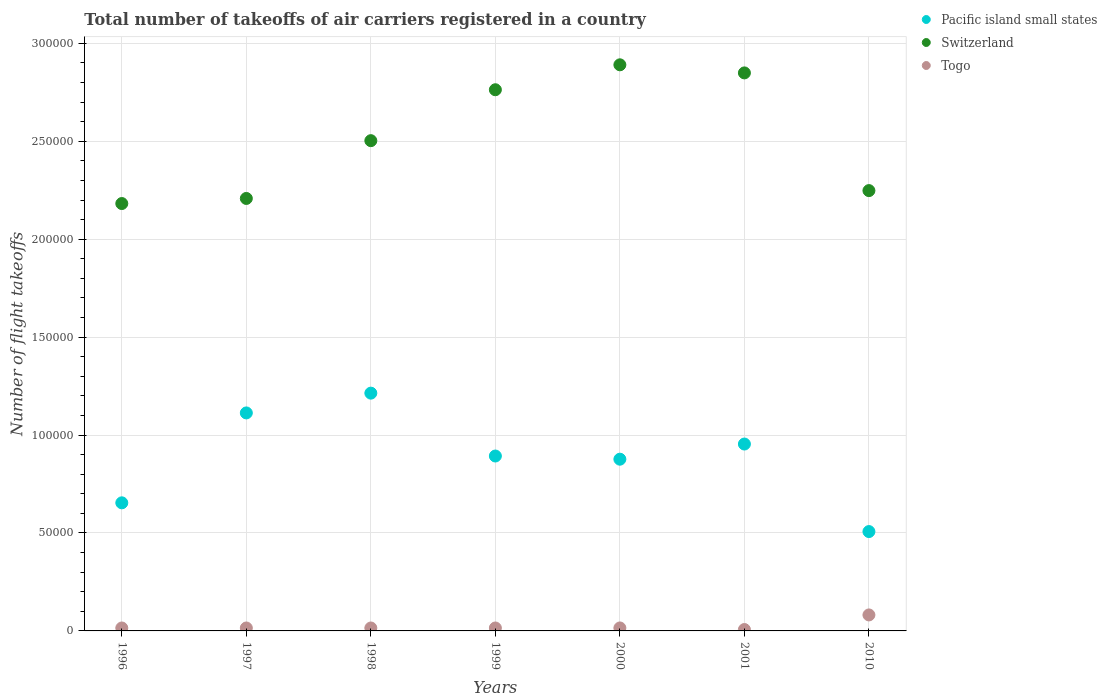How many different coloured dotlines are there?
Your response must be concise. 3. What is the total number of flight takeoffs in Togo in 2001?
Your response must be concise. 716. Across all years, what is the maximum total number of flight takeoffs in Pacific island small states?
Keep it short and to the point. 1.21e+05. Across all years, what is the minimum total number of flight takeoffs in Pacific island small states?
Provide a short and direct response. 5.07e+04. What is the total total number of flight takeoffs in Switzerland in the graph?
Keep it short and to the point. 1.76e+06. What is the difference between the total number of flight takeoffs in Togo in 2000 and that in 2001?
Your answer should be very brief. 802. What is the difference between the total number of flight takeoffs in Switzerland in 1999 and the total number of flight takeoffs in Togo in 2001?
Your answer should be compact. 2.76e+05. What is the average total number of flight takeoffs in Switzerland per year?
Your response must be concise. 2.52e+05. In the year 2001, what is the difference between the total number of flight takeoffs in Togo and total number of flight takeoffs in Switzerland?
Make the answer very short. -2.84e+05. What is the ratio of the total number of flight takeoffs in Togo in 1998 to that in 2000?
Your answer should be compact. 0.99. Is the total number of flight takeoffs in Switzerland in 2001 less than that in 2010?
Give a very brief answer. No. Is the difference between the total number of flight takeoffs in Togo in 1996 and 2010 greater than the difference between the total number of flight takeoffs in Switzerland in 1996 and 2010?
Ensure brevity in your answer.  No. What is the difference between the highest and the second highest total number of flight takeoffs in Switzerland?
Make the answer very short. 4132. What is the difference between the highest and the lowest total number of flight takeoffs in Pacific island small states?
Ensure brevity in your answer.  7.07e+04. In how many years, is the total number of flight takeoffs in Switzerland greater than the average total number of flight takeoffs in Switzerland taken over all years?
Your answer should be very brief. 3. Is the sum of the total number of flight takeoffs in Togo in 2000 and 2010 greater than the maximum total number of flight takeoffs in Switzerland across all years?
Your answer should be compact. No. Is it the case that in every year, the sum of the total number of flight takeoffs in Pacific island small states and total number of flight takeoffs in Togo  is greater than the total number of flight takeoffs in Switzerland?
Offer a very short reply. No. Is the total number of flight takeoffs in Pacific island small states strictly greater than the total number of flight takeoffs in Togo over the years?
Give a very brief answer. Yes. Is the total number of flight takeoffs in Togo strictly less than the total number of flight takeoffs in Switzerland over the years?
Provide a succinct answer. Yes. How many dotlines are there?
Give a very brief answer. 3. How many years are there in the graph?
Keep it short and to the point. 7. What is the difference between two consecutive major ticks on the Y-axis?
Offer a very short reply. 5.00e+04. Are the values on the major ticks of Y-axis written in scientific E-notation?
Your response must be concise. No. Does the graph contain grids?
Provide a short and direct response. Yes. What is the title of the graph?
Your answer should be compact. Total number of takeoffs of air carriers registered in a country. What is the label or title of the X-axis?
Provide a short and direct response. Years. What is the label or title of the Y-axis?
Provide a succinct answer. Number of flight takeoffs. What is the Number of flight takeoffs in Pacific island small states in 1996?
Offer a very short reply. 6.54e+04. What is the Number of flight takeoffs of Switzerland in 1996?
Your response must be concise. 2.18e+05. What is the Number of flight takeoffs in Togo in 1996?
Provide a short and direct response. 1500. What is the Number of flight takeoffs in Pacific island small states in 1997?
Ensure brevity in your answer.  1.11e+05. What is the Number of flight takeoffs of Switzerland in 1997?
Keep it short and to the point. 2.21e+05. What is the Number of flight takeoffs in Togo in 1997?
Ensure brevity in your answer.  1500. What is the Number of flight takeoffs of Pacific island small states in 1998?
Offer a terse response. 1.21e+05. What is the Number of flight takeoffs in Switzerland in 1998?
Ensure brevity in your answer.  2.50e+05. What is the Number of flight takeoffs of Togo in 1998?
Your answer should be compact. 1500. What is the Number of flight takeoffs of Pacific island small states in 1999?
Provide a succinct answer. 8.93e+04. What is the Number of flight takeoffs of Switzerland in 1999?
Provide a succinct answer. 2.76e+05. What is the Number of flight takeoffs of Togo in 1999?
Offer a very short reply. 1500. What is the Number of flight takeoffs in Pacific island small states in 2000?
Give a very brief answer. 8.77e+04. What is the Number of flight takeoffs of Switzerland in 2000?
Provide a succinct answer. 2.89e+05. What is the Number of flight takeoffs in Togo in 2000?
Offer a terse response. 1518. What is the Number of flight takeoffs of Pacific island small states in 2001?
Offer a terse response. 9.54e+04. What is the Number of flight takeoffs of Switzerland in 2001?
Provide a short and direct response. 2.85e+05. What is the Number of flight takeoffs in Togo in 2001?
Offer a very short reply. 716. What is the Number of flight takeoffs in Pacific island small states in 2010?
Ensure brevity in your answer.  5.07e+04. What is the Number of flight takeoffs in Switzerland in 2010?
Give a very brief answer. 2.25e+05. What is the Number of flight takeoffs in Togo in 2010?
Provide a short and direct response. 8164. Across all years, what is the maximum Number of flight takeoffs of Pacific island small states?
Provide a succinct answer. 1.21e+05. Across all years, what is the maximum Number of flight takeoffs in Switzerland?
Provide a succinct answer. 2.89e+05. Across all years, what is the maximum Number of flight takeoffs of Togo?
Provide a succinct answer. 8164. Across all years, what is the minimum Number of flight takeoffs of Pacific island small states?
Offer a terse response. 5.07e+04. Across all years, what is the minimum Number of flight takeoffs of Switzerland?
Provide a succinct answer. 2.18e+05. Across all years, what is the minimum Number of flight takeoffs of Togo?
Your response must be concise. 716. What is the total Number of flight takeoffs of Pacific island small states in the graph?
Keep it short and to the point. 6.21e+05. What is the total Number of flight takeoffs of Switzerland in the graph?
Your answer should be very brief. 1.76e+06. What is the total Number of flight takeoffs in Togo in the graph?
Offer a terse response. 1.64e+04. What is the difference between the Number of flight takeoffs of Pacific island small states in 1996 and that in 1997?
Provide a succinct answer. -4.59e+04. What is the difference between the Number of flight takeoffs of Switzerland in 1996 and that in 1997?
Keep it short and to the point. -2600. What is the difference between the Number of flight takeoffs in Pacific island small states in 1996 and that in 1998?
Your answer should be compact. -5.60e+04. What is the difference between the Number of flight takeoffs of Switzerland in 1996 and that in 1998?
Keep it short and to the point. -3.21e+04. What is the difference between the Number of flight takeoffs of Togo in 1996 and that in 1998?
Your answer should be very brief. 0. What is the difference between the Number of flight takeoffs in Pacific island small states in 1996 and that in 1999?
Offer a terse response. -2.39e+04. What is the difference between the Number of flight takeoffs in Switzerland in 1996 and that in 1999?
Provide a succinct answer. -5.81e+04. What is the difference between the Number of flight takeoffs of Pacific island small states in 1996 and that in 2000?
Offer a very short reply. -2.23e+04. What is the difference between the Number of flight takeoffs of Switzerland in 1996 and that in 2000?
Make the answer very short. -7.08e+04. What is the difference between the Number of flight takeoffs of Togo in 1996 and that in 2000?
Offer a very short reply. -18. What is the difference between the Number of flight takeoffs in Pacific island small states in 1996 and that in 2001?
Offer a terse response. -3.00e+04. What is the difference between the Number of flight takeoffs in Switzerland in 1996 and that in 2001?
Make the answer very short. -6.67e+04. What is the difference between the Number of flight takeoffs of Togo in 1996 and that in 2001?
Provide a succinct answer. 784. What is the difference between the Number of flight takeoffs in Pacific island small states in 1996 and that in 2010?
Offer a terse response. 1.47e+04. What is the difference between the Number of flight takeoffs of Switzerland in 1996 and that in 2010?
Offer a very short reply. -6607. What is the difference between the Number of flight takeoffs in Togo in 1996 and that in 2010?
Offer a very short reply. -6664. What is the difference between the Number of flight takeoffs of Pacific island small states in 1997 and that in 1998?
Make the answer very short. -1.01e+04. What is the difference between the Number of flight takeoffs in Switzerland in 1997 and that in 1998?
Your answer should be compact. -2.95e+04. What is the difference between the Number of flight takeoffs of Pacific island small states in 1997 and that in 1999?
Ensure brevity in your answer.  2.20e+04. What is the difference between the Number of flight takeoffs of Switzerland in 1997 and that in 1999?
Offer a very short reply. -5.55e+04. What is the difference between the Number of flight takeoffs in Pacific island small states in 1997 and that in 2000?
Provide a short and direct response. 2.36e+04. What is the difference between the Number of flight takeoffs of Switzerland in 1997 and that in 2000?
Offer a very short reply. -6.82e+04. What is the difference between the Number of flight takeoffs of Pacific island small states in 1997 and that in 2001?
Make the answer very short. 1.59e+04. What is the difference between the Number of flight takeoffs of Switzerland in 1997 and that in 2001?
Keep it short and to the point. -6.41e+04. What is the difference between the Number of flight takeoffs in Togo in 1997 and that in 2001?
Ensure brevity in your answer.  784. What is the difference between the Number of flight takeoffs in Pacific island small states in 1997 and that in 2010?
Provide a succinct answer. 6.06e+04. What is the difference between the Number of flight takeoffs in Switzerland in 1997 and that in 2010?
Keep it short and to the point. -4007. What is the difference between the Number of flight takeoffs in Togo in 1997 and that in 2010?
Keep it short and to the point. -6664. What is the difference between the Number of flight takeoffs of Pacific island small states in 1998 and that in 1999?
Your answer should be very brief. 3.21e+04. What is the difference between the Number of flight takeoffs in Switzerland in 1998 and that in 1999?
Keep it short and to the point. -2.60e+04. What is the difference between the Number of flight takeoffs in Togo in 1998 and that in 1999?
Provide a short and direct response. 0. What is the difference between the Number of flight takeoffs in Pacific island small states in 1998 and that in 2000?
Give a very brief answer. 3.37e+04. What is the difference between the Number of flight takeoffs in Switzerland in 1998 and that in 2000?
Offer a terse response. -3.87e+04. What is the difference between the Number of flight takeoffs of Pacific island small states in 1998 and that in 2001?
Offer a terse response. 2.60e+04. What is the difference between the Number of flight takeoffs of Switzerland in 1998 and that in 2001?
Make the answer very short. -3.46e+04. What is the difference between the Number of flight takeoffs in Togo in 1998 and that in 2001?
Offer a terse response. 784. What is the difference between the Number of flight takeoffs in Pacific island small states in 1998 and that in 2010?
Your answer should be compact. 7.07e+04. What is the difference between the Number of flight takeoffs of Switzerland in 1998 and that in 2010?
Your answer should be very brief. 2.55e+04. What is the difference between the Number of flight takeoffs of Togo in 1998 and that in 2010?
Your response must be concise. -6664. What is the difference between the Number of flight takeoffs of Pacific island small states in 1999 and that in 2000?
Give a very brief answer. 1626. What is the difference between the Number of flight takeoffs in Switzerland in 1999 and that in 2000?
Keep it short and to the point. -1.27e+04. What is the difference between the Number of flight takeoffs in Togo in 1999 and that in 2000?
Provide a short and direct response. -18. What is the difference between the Number of flight takeoffs of Pacific island small states in 1999 and that in 2001?
Give a very brief answer. -6113. What is the difference between the Number of flight takeoffs in Switzerland in 1999 and that in 2001?
Ensure brevity in your answer.  -8599. What is the difference between the Number of flight takeoffs of Togo in 1999 and that in 2001?
Give a very brief answer. 784. What is the difference between the Number of flight takeoffs of Pacific island small states in 1999 and that in 2010?
Keep it short and to the point. 3.86e+04. What is the difference between the Number of flight takeoffs of Switzerland in 1999 and that in 2010?
Offer a very short reply. 5.15e+04. What is the difference between the Number of flight takeoffs of Togo in 1999 and that in 2010?
Give a very brief answer. -6664. What is the difference between the Number of flight takeoffs of Pacific island small states in 2000 and that in 2001?
Your answer should be very brief. -7739. What is the difference between the Number of flight takeoffs in Switzerland in 2000 and that in 2001?
Your response must be concise. 4132. What is the difference between the Number of flight takeoffs in Togo in 2000 and that in 2001?
Ensure brevity in your answer.  802. What is the difference between the Number of flight takeoffs in Pacific island small states in 2000 and that in 2010?
Offer a very short reply. 3.69e+04. What is the difference between the Number of flight takeoffs in Switzerland in 2000 and that in 2010?
Provide a succinct answer. 6.42e+04. What is the difference between the Number of flight takeoffs of Togo in 2000 and that in 2010?
Your answer should be very brief. -6646. What is the difference between the Number of flight takeoffs of Pacific island small states in 2001 and that in 2010?
Offer a very short reply. 4.47e+04. What is the difference between the Number of flight takeoffs in Switzerland in 2001 and that in 2010?
Offer a terse response. 6.01e+04. What is the difference between the Number of flight takeoffs of Togo in 2001 and that in 2010?
Your answer should be very brief. -7448. What is the difference between the Number of flight takeoffs of Pacific island small states in 1996 and the Number of flight takeoffs of Switzerland in 1997?
Provide a short and direct response. -1.55e+05. What is the difference between the Number of flight takeoffs in Pacific island small states in 1996 and the Number of flight takeoffs in Togo in 1997?
Offer a very short reply. 6.39e+04. What is the difference between the Number of flight takeoffs in Switzerland in 1996 and the Number of flight takeoffs in Togo in 1997?
Offer a very short reply. 2.17e+05. What is the difference between the Number of flight takeoffs in Pacific island small states in 1996 and the Number of flight takeoffs in Switzerland in 1998?
Make the answer very short. -1.85e+05. What is the difference between the Number of flight takeoffs in Pacific island small states in 1996 and the Number of flight takeoffs in Togo in 1998?
Provide a short and direct response. 6.39e+04. What is the difference between the Number of flight takeoffs of Switzerland in 1996 and the Number of flight takeoffs of Togo in 1998?
Offer a terse response. 2.17e+05. What is the difference between the Number of flight takeoffs of Pacific island small states in 1996 and the Number of flight takeoffs of Switzerland in 1999?
Offer a terse response. -2.11e+05. What is the difference between the Number of flight takeoffs of Pacific island small states in 1996 and the Number of flight takeoffs of Togo in 1999?
Provide a short and direct response. 6.39e+04. What is the difference between the Number of flight takeoffs in Switzerland in 1996 and the Number of flight takeoffs in Togo in 1999?
Your answer should be very brief. 2.17e+05. What is the difference between the Number of flight takeoffs of Pacific island small states in 1996 and the Number of flight takeoffs of Switzerland in 2000?
Ensure brevity in your answer.  -2.24e+05. What is the difference between the Number of flight takeoffs in Pacific island small states in 1996 and the Number of flight takeoffs in Togo in 2000?
Keep it short and to the point. 6.39e+04. What is the difference between the Number of flight takeoffs of Switzerland in 1996 and the Number of flight takeoffs of Togo in 2000?
Offer a very short reply. 2.17e+05. What is the difference between the Number of flight takeoffs in Pacific island small states in 1996 and the Number of flight takeoffs in Switzerland in 2001?
Your answer should be compact. -2.19e+05. What is the difference between the Number of flight takeoffs in Pacific island small states in 1996 and the Number of flight takeoffs in Togo in 2001?
Ensure brevity in your answer.  6.47e+04. What is the difference between the Number of flight takeoffs in Switzerland in 1996 and the Number of flight takeoffs in Togo in 2001?
Your answer should be compact. 2.17e+05. What is the difference between the Number of flight takeoffs in Pacific island small states in 1996 and the Number of flight takeoffs in Switzerland in 2010?
Give a very brief answer. -1.59e+05. What is the difference between the Number of flight takeoffs in Pacific island small states in 1996 and the Number of flight takeoffs in Togo in 2010?
Offer a terse response. 5.72e+04. What is the difference between the Number of flight takeoffs of Switzerland in 1996 and the Number of flight takeoffs of Togo in 2010?
Make the answer very short. 2.10e+05. What is the difference between the Number of flight takeoffs in Pacific island small states in 1997 and the Number of flight takeoffs in Switzerland in 1998?
Your answer should be compact. -1.39e+05. What is the difference between the Number of flight takeoffs in Pacific island small states in 1997 and the Number of flight takeoffs in Togo in 1998?
Ensure brevity in your answer.  1.10e+05. What is the difference between the Number of flight takeoffs in Switzerland in 1997 and the Number of flight takeoffs in Togo in 1998?
Make the answer very short. 2.19e+05. What is the difference between the Number of flight takeoffs in Pacific island small states in 1997 and the Number of flight takeoffs in Switzerland in 1999?
Provide a short and direct response. -1.65e+05. What is the difference between the Number of flight takeoffs in Pacific island small states in 1997 and the Number of flight takeoffs in Togo in 1999?
Offer a terse response. 1.10e+05. What is the difference between the Number of flight takeoffs in Switzerland in 1997 and the Number of flight takeoffs in Togo in 1999?
Offer a very short reply. 2.19e+05. What is the difference between the Number of flight takeoffs in Pacific island small states in 1997 and the Number of flight takeoffs in Switzerland in 2000?
Your response must be concise. -1.78e+05. What is the difference between the Number of flight takeoffs in Pacific island small states in 1997 and the Number of flight takeoffs in Togo in 2000?
Provide a short and direct response. 1.10e+05. What is the difference between the Number of flight takeoffs of Switzerland in 1997 and the Number of flight takeoffs of Togo in 2000?
Your response must be concise. 2.19e+05. What is the difference between the Number of flight takeoffs of Pacific island small states in 1997 and the Number of flight takeoffs of Switzerland in 2001?
Provide a short and direct response. -1.74e+05. What is the difference between the Number of flight takeoffs of Pacific island small states in 1997 and the Number of flight takeoffs of Togo in 2001?
Your response must be concise. 1.11e+05. What is the difference between the Number of flight takeoffs in Switzerland in 1997 and the Number of flight takeoffs in Togo in 2001?
Make the answer very short. 2.20e+05. What is the difference between the Number of flight takeoffs of Pacific island small states in 1997 and the Number of flight takeoffs of Switzerland in 2010?
Make the answer very short. -1.14e+05. What is the difference between the Number of flight takeoffs in Pacific island small states in 1997 and the Number of flight takeoffs in Togo in 2010?
Give a very brief answer. 1.03e+05. What is the difference between the Number of flight takeoffs in Switzerland in 1997 and the Number of flight takeoffs in Togo in 2010?
Provide a short and direct response. 2.13e+05. What is the difference between the Number of flight takeoffs of Pacific island small states in 1998 and the Number of flight takeoffs of Switzerland in 1999?
Ensure brevity in your answer.  -1.55e+05. What is the difference between the Number of flight takeoffs of Pacific island small states in 1998 and the Number of flight takeoffs of Togo in 1999?
Your answer should be very brief. 1.20e+05. What is the difference between the Number of flight takeoffs in Switzerland in 1998 and the Number of flight takeoffs in Togo in 1999?
Offer a terse response. 2.49e+05. What is the difference between the Number of flight takeoffs in Pacific island small states in 1998 and the Number of flight takeoffs in Switzerland in 2000?
Make the answer very short. -1.68e+05. What is the difference between the Number of flight takeoffs of Pacific island small states in 1998 and the Number of flight takeoffs of Togo in 2000?
Ensure brevity in your answer.  1.20e+05. What is the difference between the Number of flight takeoffs in Switzerland in 1998 and the Number of flight takeoffs in Togo in 2000?
Give a very brief answer. 2.49e+05. What is the difference between the Number of flight takeoffs in Pacific island small states in 1998 and the Number of flight takeoffs in Switzerland in 2001?
Keep it short and to the point. -1.63e+05. What is the difference between the Number of flight takeoffs in Pacific island small states in 1998 and the Number of flight takeoffs in Togo in 2001?
Make the answer very short. 1.21e+05. What is the difference between the Number of flight takeoffs in Switzerland in 1998 and the Number of flight takeoffs in Togo in 2001?
Offer a terse response. 2.50e+05. What is the difference between the Number of flight takeoffs in Pacific island small states in 1998 and the Number of flight takeoffs in Switzerland in 2010?
Provide a short and direct response. -1.03e+05. What is the difference between the Number of flight takeoffs in Pacific island small states in 1998 and the Number of flight takeoffs in Togo in 2010?
Provide a succinct answer. 1.13e+05. What is the difference between the Number of flight takeoffs of Switzerland in 1998 and the Number of flight takeoffs of Togo in 2010?
Make the answer very short. 2.42e+05. What is the difference between the Number of flight takeoffs in Pacific island small states in 1999 and the Number of flight takeoffs in Switzerland in 2000?
Your answer should be very brief. -2.00e+05. What is the difference between the Number of flight takeoffs in Pacific island small states in 1999 and the Number of flight takeoffs in Togo in 2000?
Offer a very short reply. 8.78e+04. What is the difference between the Number of flight takeoffs in Switzerland in 1999 and the Number of flight takeoffs in Togo in 2000?
Your response must be concise. 2.75e+05. What is the difference between the Number of flight takeoffs of Pacific island small states in 1999 and the Number of flight takeoffs of Switzerland in 2001?
Your answer should be compact. -1.96e+05. What is the difference between the Number of flight takeoffs of Pacific island small states in 1999 and the Number of flight takeoffs of Togo in 2001?
Ensure brevity in your answer.  8.86e+04. What is the difference between the Number of flight takeoffs in Switzerland in 1999 and the Number of flight takeoffs in Togo in 2001?
Your answer should be very brief. 2.76e+05. What is the difference between the Number of flight takeoffs of Pacific island small states in 1999 and the Number of flight takeoffs of Switzerland in 2010?
Your answer should be compact. -1.36e+05. What is the difference between the Number of flight takeoffs in Pacific island small states in 1999 and the Number of flight takeoffs in Togo in 2010?
Give a very brief answer. 8.11e+04. What is the difference between the Number of flight takeoffs in Switzerland in 1999 and the Number of flight takeoffs in Togo in 2010?
Ensure brevity in your answer.  2.68e+05. What is the difference between the Number of flight takeoffs in Pacific island small states in 2000 and the Number of flight takeoffs in Switzerland in 2001?
Your response must be concise. -1.97e+05. What is the difference between the Number of flight takeoffs of Pacific island small states in 2000 and the Number of flight takeoffs of Togo in 2001?
Offer a very short reply. 8.70e+04. What is the difference between the Number of flight takeoffs in Switzerland in 2000 and the Number of flight takeoffs in Togo in 2001?
Make the answer very short. 2.88e+05. What is the difference between the Number of flight takeoffs of Pacific island small states in 2000 and the Number of flight takeoffs of Switzerland in 2010?
Offer a very short reply. -1.37e+05. What is the difference between the Number of flight takeoffs of Pacific island small states in 2000 and the Number of flight takeoffs of Togo in 2010?
Provide a succinct answer. 7.95e+04. What is the difference between the Number of flight takeoffs of Switzerland in 2000 and the Number of flight takeoffs of Togo in 2010?
Ensure brevity in your answer.  2.81e+05. What is the difference between the Number of flight takeoffs of Pacific island small states in 2001 and the Number of flight takeoffs of Switzerland in 2010?
Keep it short and to the point. -1.29e+05. What is the difference between the Number of flight takeoffs of Pacific island small states in 2001 and the Number of flight takeoffs of Togo in 2010?
Provide a short and direct response. 8.72e+04. What is the difference between the Number of flight takeoffs of Switzerland in 2001 and the Number of flight takeoffs of Togo in 2010?
Offer a terse response. 2.77e+05. What is the average Number of flight takeoffs in Pacific island small states per year?
Your response must be concise. 8.87e+04. What is the average Number of flight takeoffs of Switzerland per year?
Your answer should be very brief. 2.52e+05. What is the average Number of flight takeoffs in Togo per year?
Your answer should be compact. 2342.57. In the year 1996, what is the difference between the Number of flight takeoffs of Pacific island small states and Number of flight takeoffs of Switzerland?
Your response must be concise. -1.53e+05. In the year 1996, what is the difference between the Number of flight takeoffs in Pacific island small states and Number of flight takeoffs in Togo?
Offer a terse response. 6.39e+04. In the year 1996, what is the difference between the Number of flight takeoffs in Switzerland and Number of flight takeoffs in Togo?
Provide a short and direct response. 2.17e+05. In the year 1997, what is the difference between the Number of flight takeoffs of Pacific island small states and Number of flight takeoffs of Switzerland?
Provide a short and direct response. -1.10e+05. In the year 1997, what is the difference between the Number of flight takeoffs of Pacific island small states and Number of flight takeoffs of Togo?
Offer a terse response. 1.10e+05. In the year 1997, what is the difference between the Number of flight takeoffs in Switzerland and Number of flight takeoffs in Togo?
Your answer should be very brief. 2.19e+05. In the year 1998, what is the difference between the Number of flight takeoffs in Pacific island small states and Number of flight takeoffs in Switzerland?
Provide a short and direct response. -1.29e+05. In the year 1998, what is the difference between the Number of flight takeoffs in Pacific island small states and Number of flight takeoffs in Togo?
Ensure brevity in your answer.  1.20e+05. In the year 1998, what is the difference between the Number of flight takeoffs in Switzerland and Number of flight takeoffs in Togo?
Your answer should be very brief. 2.49e+05. In the year 1999, what is the difference between the Number of flight takeoffs in Pacific island small states and Number of flight takeoffs in Switzerland?
Offer a very short reply. -1.87e+05. In the year 1999, what is the difference between the Number of flight takeoffs of Pacific island small states and Number of flight takeoffs of Togo?
Provide a short and direct response. 8.78e+04. In the year 1999, what is the difference between the Number of flight takeoffs in Switzerland and Number of flight takeoffs in Togo?
Ensure brevity in your answer.  2.75e+05. In the year 2000, what is the difference between the Number of flight takeoffs in Pacific island small states and Number of flight takeoffs in Switzerland?
Give a very brief answer. -2.01e+05. In the year 2000, what is the difference between the Number of flight takeoffs in Pacific island small states and Number of flight takeoffs in Togo?
Your answer should be very brief. 8.62e+04. In the year 2000, what is the difference between the Number of flight takeoffs of Switzerland and Number of flight takeoffs of Togo?
Your answer should be compact. 2.88e+05. In the year 2001, what is the difference between the Number of flight takeoffs of Pacific island small states and Number of flight takeoffs of Switzerland?
Keep it short and to the point. -1.89e+05. In the year 2001, what is the difference between the Number of flight takeoffs of Pacific island small states and Number of flight takeoffs of Togo?
Your response must be concise. 9.47e+04. In the year 2001, what is the difference between the Number of flight takeoffs of Switzerland and Number of flight takeoffs of Togo?
Give a very brief answer. 2.84e+05. In the year 2010, what is the difference between the Number of flight takeoffs of Pacific island small states and Number of flight takeoffs of Switzerland?
Offer a very short reply. -1.74e+05. In the year 2010, what is the difference between the Number of flight takeoffs in Pacific island small states and Number of flight takeoffs in Togo?
Your response must be concise. 4.26e+04. In the year 2010, what is the difference between the Number of flight takeoffs of Switzerland and Number of flight takeoffs of Togo?
Provide a succinct answer. 2.17e+05. What is the ratio of the Number of flight takeoffs of Pacific island small states in 1996 to that in 1997?
Your answer should be compact. 0.59. What is the ratio of the Number of flight takeoffs of Switzerland in 1996 to that in 1997?
Your answer should be compact. 0.99. What is the ratio of the Number of flight takeoffs of Pacific island small states in 1996 to that in 1998?
Your answer should be compact. 0.54. What is the ratio of the Number of flight takeoffs in Switzerland in 1996 to that in 1998?
Keep it short and to the point. 0.87. What is the ratio of the Number of flight takeoffs of Pacific island small states in 1996 to that in 1999?
Your response must be concise. 0.73. What is the ratio of the Number of flight takeoffs in Switzerland in 1996 to that in 1999?
Your answer should be very brief. 0.79. What is the ratio of the Number of flight takeoffs of Togo in 1996 to that in 1999?
Offer a terse response. 1. What is the ratio of the Number of flight takeoffs in Pacific island small states in 1996 to that in 2000?
Make the answer very short. 0.75. What is the ratio of the Number of flight takeoffs in Switzerland in 1996 to that in 2000?
Give a very brief answer. 0.75. What is the ratio of the Number of flight takeoffs of Pacific island small states in 1996 to that in 2001?
Offer a very short reply. 0.69. What is the ratio of the Number of flight takeoffs of Switzerland in 1996 to that in 2001?
Your answer should be very brief. 0.77. What is the ratio of the Number of flight takeoffs in Togo in 1996 to that in 2001?
Make the answer very short. 2.1. What is the ratio of the Number of flight takeoffs of Pacific island small states in 1996 to that in 2010?
Your answer should be very brief. 1.29. What is the ratio of the Number of flight takeoffs in Switzerland in 1996 to that in 2010?
Give a very brief answer. 0.97. What is the ratio of the Number of flight takeoffs of Togo in 1996 to that in 2010?
Offer a very short reply. 0.18. What is the ratio of the Number of flight takeoffs of Pacific island small states in 1997 to that in 1998?
Provide a short and direct response. 0.92. What is the ratio of the Number of flight takeoffs in Switzerland in 1997 to that in 1998?
Provide a short and direct response. 0.88. What is the ratio of the Number of flight takeoffs in Togo in 1997 to that in 1998?
Your answer should be very brief. 1. What is the ratio of the Number of flight takeoffs of Pacific island small states in 1997 to that in 1999?
Your answer should be very brief. 1.25. What is the ratio of the Number of flight takeoffs of Switzerland in 1997 to that in 1999?
Your answer should be compact. 0.8. What is the ratio of the Number of flight takeoffs of Pacific island small states in 1997 to that in 2000?
Offer a terse response. 1.27. What is the ratio of the Number of flight takeoffs of Switzerland in 1997 to that in 2000?
Ensure brevity in your answer.  0.76. What is the ratio of the Number of flight takeoffs of Pacific island small states in 1997 to that in 2001?
Keep it short and to the point. 1.17. What is the ratio of the Number of flight takeoffs of Switzerland in 1997 to that in 2001?
Give a very brief answer. 0.78. What is the ratio of the Number of flight takeoffs of Togo in 1997 to that in 2001?
Offer a terse response. 2.1. What is the ratio of the Number of flight takeoffs of Pacific island small states in 1997 to that in 2010?
Your response must be concise. 2.19. What is the ratio of the Number of flight takeoffs in Switzerland in 1997 to that in 2010?
Your response must be concise. 0.98. What is the ratio of the Number of flight takeoffs in Togo in 1997 to that in 2010?
Give a very brief answer. 0.18. What is the ratio of the Number of flight takeoffs of Pacific island small states in 1998 to that in 1999?
Give a very brief answer. 1.36. What is the ratio of the Number of flight takeoffs of Switzerland in 1998 to that in 1999?
Your answer should be compact. 0.91. What is the ratio of the Number of flight takeoffs in Pacific island small states in 1998 to that in 2000?
Your answer should be very brief. 1.38. What is the ratio of the Number of flight takeoffs of Switzerland in 1998 to that in 2000?
Provide a succinct answer. 0.87. What is the ratio of the Number of flight takeoffs of Pacific island small states in 1998 to that in 2001?
Keep it short and to the point. 1.27. What is the ratio of the Number of flight takeoffs in Switzerland in 1998 to that in 2001?
Make the answer very short. 0.88. What is the ratio of the Number of flight takeoffs in Togo in 1998 to that in 2001?
Keep it short and to the point. 2.1. What is the ratio of the Number of flight takeoffs of Pacific island small states in 1998 to that in 2010?
Ensure brevity in your answer.  2.39. What is the ratio of the Number of flight takeoffs in Switzerland in 1998 to that in 2010?
Provide a short and direct response. 1.11. What is the ratio of the Number of flight takeoffs in Togo in 1998 to that in 2010?
Your answer should be compact. 0.18. What is the ratio of the Number of flight takeoffs of Pacific island small states in 1999 to that in 2000?
Offer a very short reply. 1.02. What is the ratio of the Number of flight takeoffs of Switzerland in 1999 to that in 2000?
Offer a very short reply. 0.96. What is the ratio of the Number of flight takeoffs in Pacific island small states in 1999 to that in 2001?
Your answer should be compact. 0.94. What is the ratio of the Number of flight takeoffs in Switzerland in 1999 to that in 2001?
Give a very brief answer. 0.97. What is the ratio of the Number of flight takeoffs of Togo in 1999 to that in 2001?
Offer a terse response. 2.1. What is the ratio of the Number of flight takeoffs in Pacific island small states in 1999 to that in 2010?
Provide a short and direct response. 1.76. What is the ratio of the Number of flight takeoffs in Switzerland in 1999 to that in 2010?
Your response must be concise. 1.23. What is the ratio of the Number of flight takeoffs in Togo in 1999 to that in 2010?
Your answer should be compact. 0.18. What is the ratio of the Number of flight takeoffs in Pacific island small states in 2000 to that in 2001?
Your answer should be compact. 0.92. What is the ratio of the Number of flight takeoffs of Switzerland in 2000 to that in 2001?
Your answer should be very brief. 1.01. What is the ratio of the Number of flight takeoffs in Togo in 2000 to that in 2001?
Provide a short and direct response. 2.12. What is the ratio of the Number of flight takeoffs of Pacific island small states in 2000 to that in 2010?
Provide a succinct answer. 1.73. What is the ratio of the Number of flight takeoffs in Switzerland in 2000 to that in 2010?
Your answer should be very brief. 1.29. What is the ratio of the Number of flight takeoffs in Togo in 2000 to that in 2010?
Your answer should be compact. 0.19. What is the ratio of the Number of flight takeoffs of Pacific island small states in 2001 to that in 2010?
Your answer should be very brief. 1.88. What is the ratio of the Number of flight takeoffs in Switzerland in 2001 to that in 2010?
Provide a succinct answer. 1.27. What is the ratio of the Number of flight takeoffs in Togo in 2001 to that in 2010?
Provide a succinct answer. 0.09. What is the difference between the highest and the second highest Number of flight takeoffs in Pacific island small states?
Keep it short and to the point. 1.01e+04. What is the difference between the highest and the second highest Number of flight takeoffs of Switzerland?
Make the answer very short. 4132. What is the difference between the highest and the second highest Number of flight takeoffs in Togo?
Keep it short and to the point. 6646. What is the difference between the highest and the lowest Number of flight takeoffs in Pacific island small states?
Offer a very short reply. 7.07e+04. What is the difference between the highest and the lowest Number of flight takeoffs in Switzerland?
Your answer should be compact. 7.08e+04. What is the difference between the highest and the lowest Number of flight takeoffs in Togo?
Provide a succinct answer. 7448. 